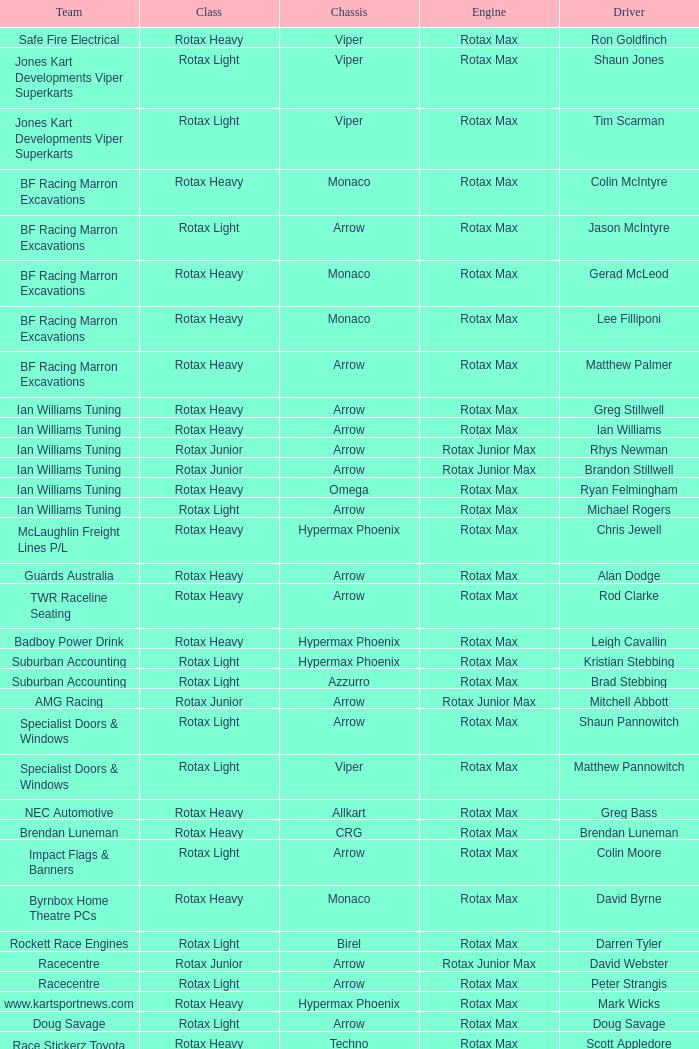Would you mind parsing the complete table? {'header': ['Team', 'Class', 'Chassis', 'Engine', 'Driver'], 'rows': [['Safe Fire Electrical', 'Rotax Heavy', 'Viper', 'Rotax Max', 'Ron Goldfinch'], ['Jones Kart Developments Viper Superkarts', 'Rotax Light', 'Viper', 'Rotax Max', 'Shaun Jones'], ['Jones Kart Developments Viper Superkarts', 'Rotax Light', 'Viper', 'Rotax Max', 'Tim Scarman'], ['BF Racing Marron Excavations', 'Rotax Heavy', 'Monaco', 'Rotax Max', 'Colin McIntyre'], ['BF Racing Marron Excavations', 'Rotax Light', 'Arrow', 'Rotax Max', 'Jason McIntyre'], ['BF Racing Marron Excavations', 'Rotax Heavy', 'Monaco', 'Rotax Max', 'Gerad McLeod'], ['BF Racing Marron Excavations', 'Rotax Heavy', 'Monaco', 'Rotax Max', 'Lee Filliponi'], ['BF Racing Marron Excavations', 'Rotax Heavy', 'Arrow', 'Rotax Max', 'Matthew Palmer'], ['Ian Williams Tuning', 'Rotax Heavy', 'Arrow', 'Rotax Max', 'Greg Stillwell'], ['Ian Williams Tuning', 'Rotax Heavy', 'Arrow', 'Rotax Max', 'Ian Williams'], ['Ian Williams Tuning', 'Rotax Junior', 'Arrow', 'Rotax Junior Max', 'Rhys Newman'], ['Ian Williams Tuning', 'Rotax Junior', 'Arrow', 'Rotax Junior Max', 'Brandon Stillwell'], ['Ian Williams Tuning', 'Rotax Heavy', 'Omega', 'Rotax Max', 'Ryan Felmingham'], ['Ian Williams Tuning', 'Rotax Light', 'Arrow', 'Rotax Max', 'Michael Rogers'], ['McLaughlin Freight Lines P/L', 'Rotax Heavy', 'Hypermax Phoenix', 'Rotax Max', 'Chris Jewell'], ['Guards Australia', 'Rotax Heavy', 'Arrow', 'Rotax Max', 'Alan Dodge'], ['TWR Raceline Seating', 'Rotax Heavy', 'Arrow', 'Rotax Max', 'Rod Clarke'], ['Badboy Power Drink', 'Rotax Heavy', 'Hypermax Phoenix', 'Rotax Max', 'Leigh Cavallin'], ['Suburban Accounting', 'Rotax Light', 'Hypermax Phoenix', 'Rotax Max', 'Kristian Stebbing'], ['Suburban Accounting', 'Rotax Light', 'Azzurro', 'Rotax Max', 'Brad Stebbing'], ['AMG Racing', 'Rotax Junior', 'Arrow', 'Rotax Junior Max', 'Mitchell Abbott'], ['Specialist Doors & Windows', 'Rotax Light', 'Arrow', 'Rotax Max', 'Shaun Pannowitch'], ['Specialist Doors & Windows', 'Rotax Light', 'Viper', 'Rotax Max', 'Matthew Pannowitch'], ['NEC Automotive', 'Rotax Heavy', 'Allkart', 'Rotax Max', 'Greg Bass'], ['Brendan Luneman', 'Rotax Heavy', 'CRG', 'Rotax Max', 'Brendan Luneman'], ['Impact Flags & Banners', 'Rotax Light', 'Arrow', 'Rotax Max', 'Colin Moore'], ['Byrnbox Home Theatre PCs', 'Rotax Heavy', 'Monaco', 'Rotax Max', 'David Byrne'], ['Rockett Race Engines', 'Rotax Light', 'Birel', 'Rotax Max', 'Darren Tyler'], ['Racecentre', 'Rotax Junior', 'Arrow', 'Rotax Junior Max', 'David Webster'], ['Racecentre', 'Rotax Light', 'Arrow', 'Rotax Max', 'Peter Strangis'], ['www.kartsportnews.com', 'Rotax Heavy', 'Hypermax Phoenix', 'Rotax Max', 'Mark Wicks'], ['Doug Savage', 'Rotax Light', 'Arrow', 'Rotax Max', 'Doug Savage'], ['Race Stickerz Toyota Material Handling', 'Rotax Heavy', 'Techno', 'Rotax Max', 'Scott Appledore'], ['Wild Digital', 'Rotax Junior', 'Hypermax Phoenix', 'Rotax Junior Max', 'Sean Whitfield'], ['John Bartlett', 'Rotax Heavy', 'Hypermax Phoenix', 'Rotax Max', 'John Bartlett']]} What is the name of the driver with a rotax max engine, in the rotax heavy class, with arrow as chassis and on the TWR Raceline Seating team? Rod Clarke. 